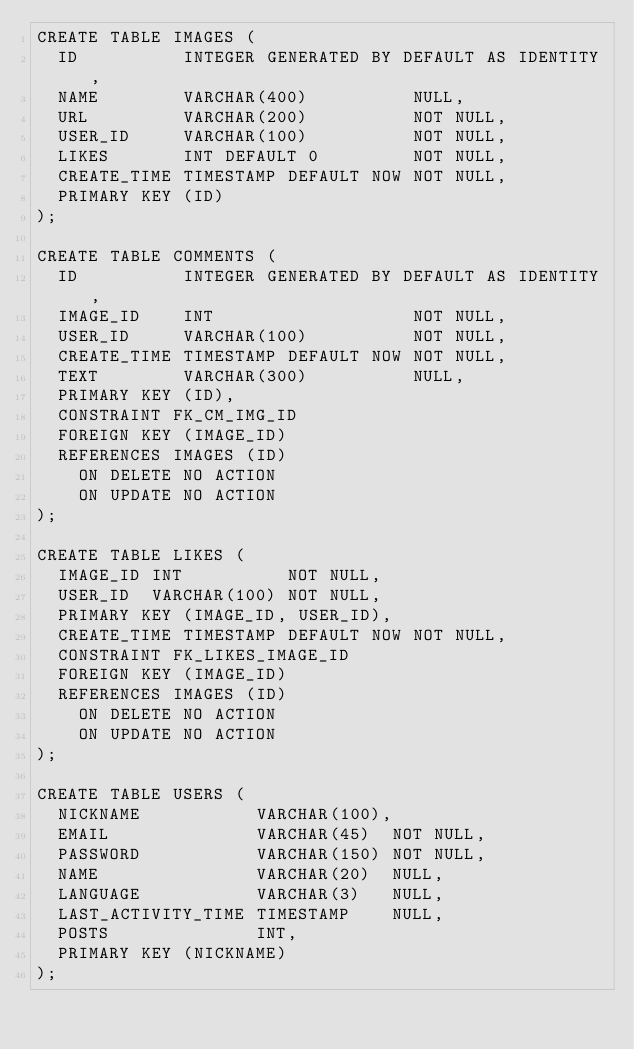<code> <loc_0><loc_0><loc_500><loc_500><_SQL_>CREATE TABLE IMAGES (
  ID          INTEGER GENERATED BY DEFAULT AS IDENTITY,
  NAME        VARCHAR(400)          NULL,
  URL         VARCHAR(200)          NOT NULL,
  USER_ID     VARCHAR(100)          NOT NULL,
  LIKES       INT DEFAULT 0         NOT NULL,
  CREATE_TIME TIMESTAMP DEFAULT NOW NOT NULL,
  PRIMARY KEY (ID)
);

CREATE TABLE COMMENTS (
  ID          INTEGER GENERATED BY DEFAULT AS IDENTITY,
  IMAGE_ID    INT                   NOT NULL,
  USER_ID     VARCHAR(100)          NOT NULL,
  CREATE_TIME TIMESTAMP DEFAULT NOW NOT NULL,
  TEXT        VARCHAR(300)          NULL,
  PRIMARY KEY (ID),
  CONSTRAINT FK_CM_IMG_ID
  FOREIGN KEY (IMAGE_ID)
  REFERENCES IMAGES (ID)
    ON DELETE NO ACTION
    ON UPDATE NO ACTION
);

CREATE TABLE LIKES (
  IMAGE_ID INT          NOT NULL,
  USER_ID  VARCHAR(100) NOT NULL,
  PRIMARY KEY (IMAGE_ID, USER_ID),
  CREATE_TIME TIMESTAMP DEFAULT NOW NOT NULL,
  CONSTRAINT FK_LIKES_IMAGE_ID
  FOREIGN KEY (IMAGE_ID)
  REFERENCES IMAGES (ID)
    ON DELETE NO ACTION
    ON UPDATE NO ACTION
);

CREATE TABLE USERS (
  NICKNAME           VARCHAR(100),
  EMAIL              VARCHAR(45)  NOT NULL,
  PASSWORD           VARCHAR(150) NOT NULL,
  NAME               VARCHAR(20)  NULL,
  LANGUAGE           VARCHAR(3)   NULL,
  LAST_ACTIVITY_TIME TIMESTAMP    NULL,
  POSTS              INT,
  PRIMARY KEY (NICKNAME)
);</code> 